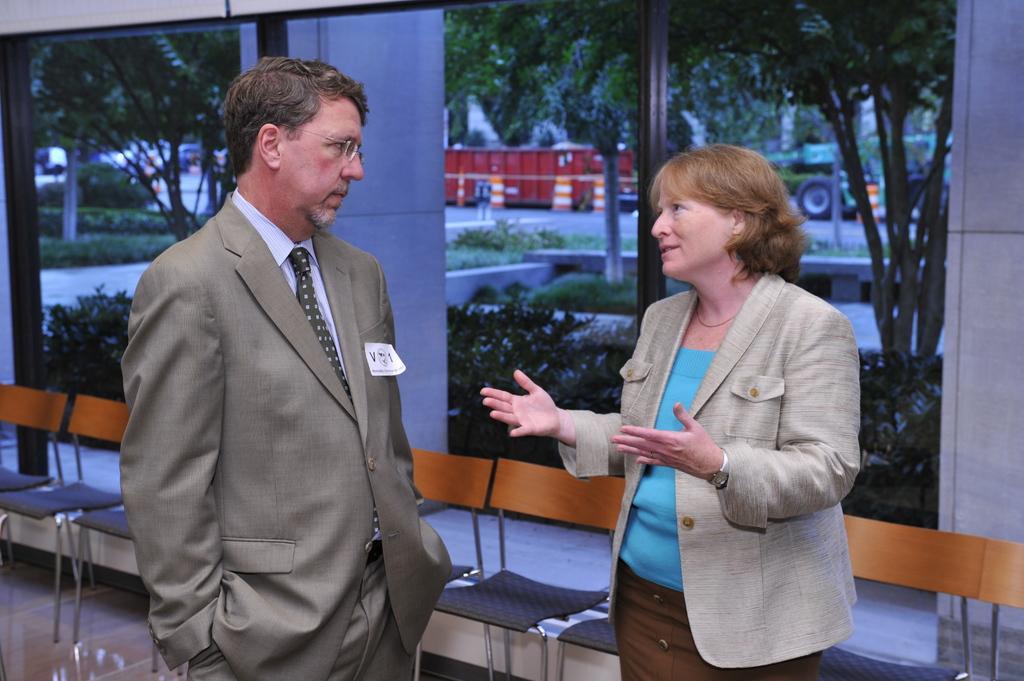Please provide a concise description of this image. In this picture we can see a man and a woman are standing, there are some chairs in the front, in the background we can see a container, a vehicle, some trees, plants and a person, it looks like a glass in the middle. 